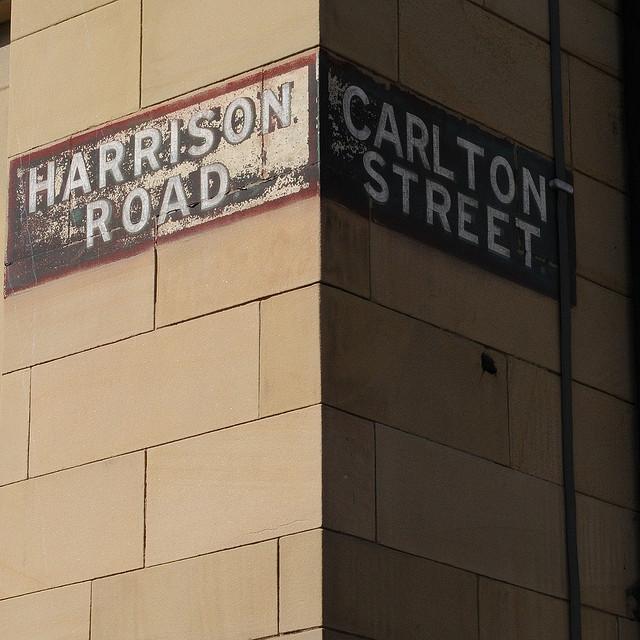What stop is this?
Write a very short answer. Harrison road. What corner is this?
Concise answer only. Harrison and carlton. What does this say?
Write a very short answer. Harrison road carlton street. What is the name of the road that starts with a c?
Keep it brief. Carlton. What is the name of the road that starts with H?
Write a very short answer. Harrison. 